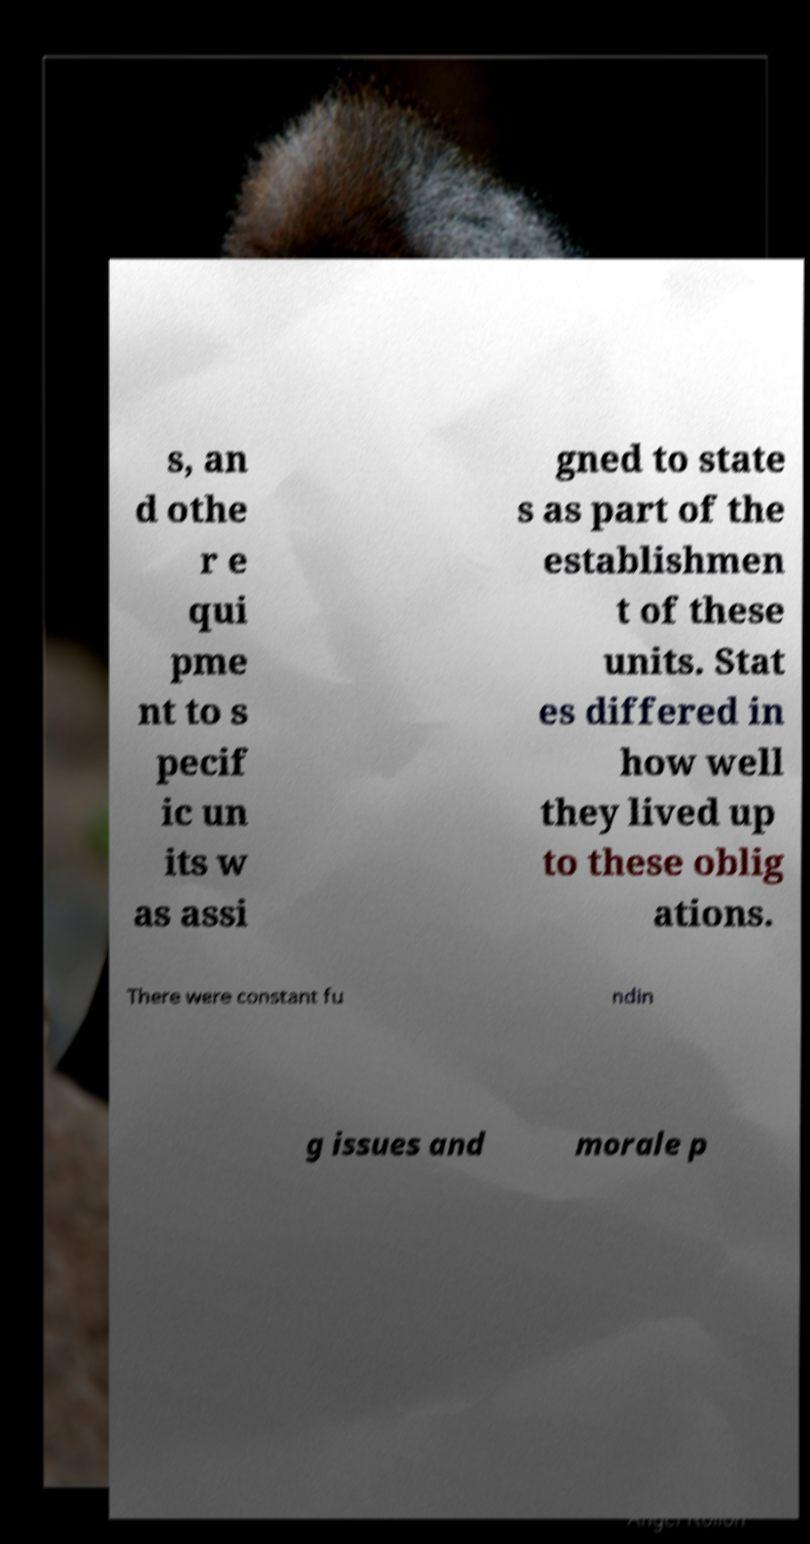Can you read and provide the text displayed in the image?This photo seems to have some interesting text. Can you extract and type it out for me? s, an d othe r e qui pme nt to s pecif ic un its w as assi gned to state s as part of the establishmen t of these units. Stat es differed in how well they lived up to these oblig ations. There were constant fu ndin g issues and morale p 